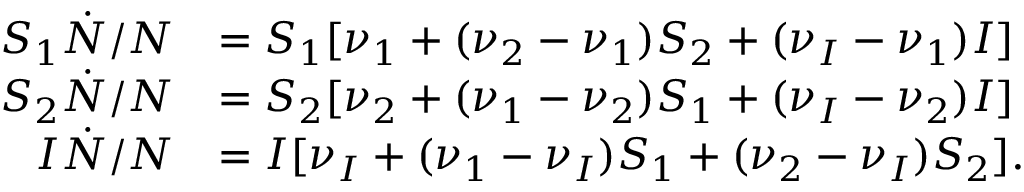Convert formula to latex. <formula><loc_0><loc_0><loc_500><loc_500>\begin{array} { r l } { S _ { 1 } \dot { N } / N } & { = S _ { 1 } [ \nu _ { 1 } + ( \nu _ { 2 } - \nu _ { 1 } ) S _ { 2 } + ( \nu _ { I } - \nu _ { 1 } ) I ] } \\ { S _ { 2 } \dot { N } / N } & { = S _ { 2 } [ \nu _ { 2 } + ( \nu _ { 1 } - \nu _ { 2 } ) S _ { 1 } + ( \nu _ { I } - \nu _ { 2 } ) I ] } \\ { I \dot { N } / N } & { = I [ \nu _ { I } + ( \nu _ { 1 } - \nu _ { I } ) S _ { 1 } + ( \nu _ { 2 } - \nu _ { I } ) S _ { 2 } ] . } \end{array}</formula> 